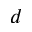Convert formula to latex. <formula><loc_0><loc_0><loc_500><loc_500>d</formula> 